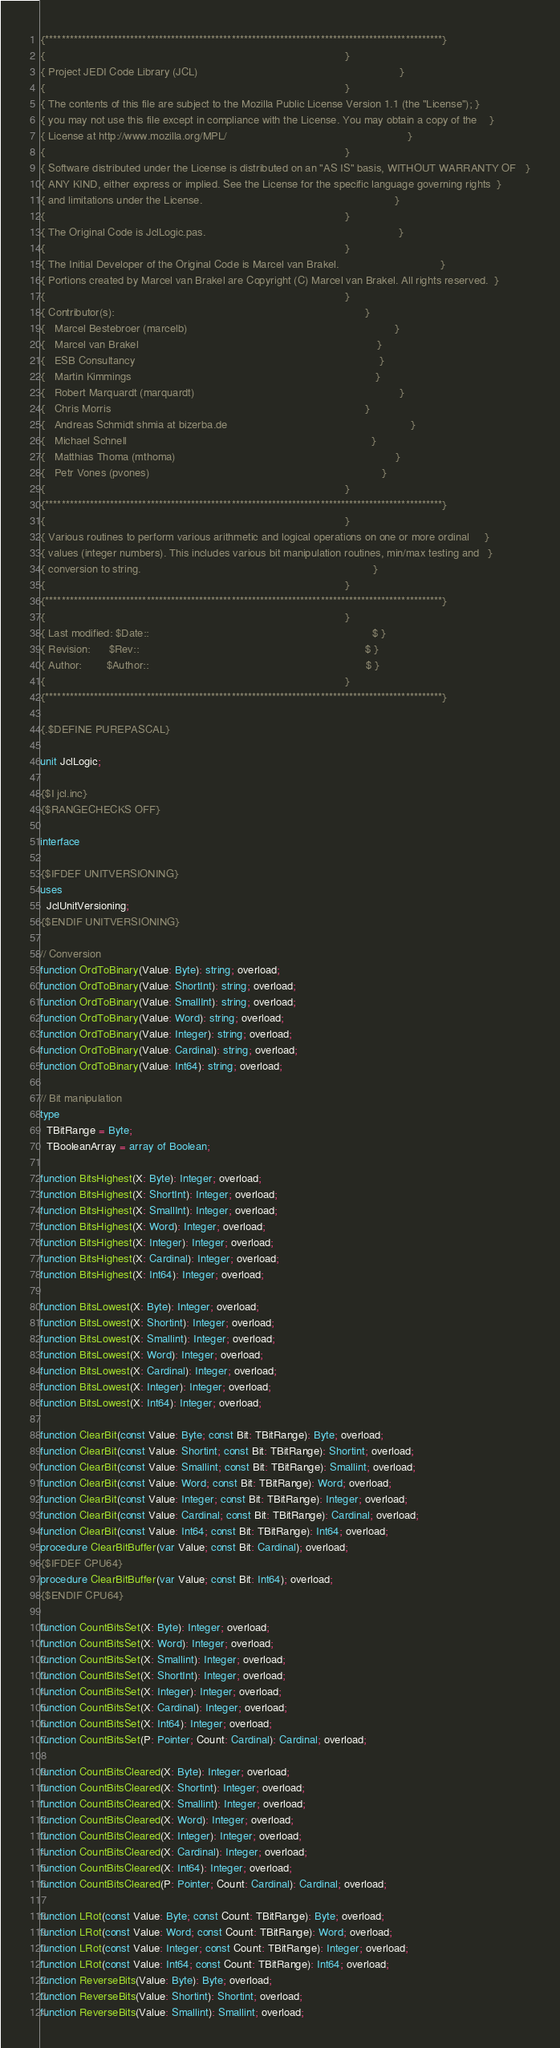<code> <loc_0><loc_0><loc_500><loc_500><_Pascal_>{**************************************************************************************************}
{                                                                                                  }
{ Project JEDI Code Library (JCL)                                                                  }
{                                                                                                  }
{ The contents of this file are subject to the Mozilla Public License Version 1.1 (the "License"); }
{ you may not use this file except in compliance with the License. You may obtain a copy of the    }
{ License at http://www.mozilla.org/MPL/                                                           }
{                                                                                                  }
{ Software distributed under the License is distributed on an "AS IS" basis, WITHOUT WARRANTY OF   }
{ ANY KIND, either express or implied. See the License for the specific language governing rights  }
{ and limitations under the License.                                                               }
{                                                                                                  }
{ The Original Code is JclLogic.pas.                                                               }
{                                                                                                  }
{ The Initial Developer of the Original Code is Marcel van Brakel.                                 }
{ Portions created by Marcel van Brakel are Copyright (C) Marcel van Brakel. All rights reserved.  }
{                                                                                                  }
{ Contributor(s):                                                                                  }
{   Marcel Bestebroer (marcelb)                                                                    }
{   Marcel van Brakel                                                                              }
{   ESB Consultancy                                                                                }
{   Martin Kimmings                                                                                }
{   Robert Marquardt (marquardt)                                                                   }
{   Chris Morris                                                                                   }
{   Andreas Schmidt shmia at bizerba.de                                                            }
{   Michael Schnell                                                                                }
{   Matthias Thoma (mthoma)                                                                        }
{   Petr Vones (pvones)                                                                            }
{                                                                                                  }
{**************************************************************************************************}
{                                                                                                  }
{ Various routines to perform various arithmetic and logical operations on one or more ordinal     }
{ values (integer numbers). This includes various bit manipulation routines, min/max testing and   }
{ conversion to string.                                                                            }
{                                                                                                  }
{**************************************************************************************************}
{                                                                                                  }
{ Last modified: $Date::                                                                         $ }
{ Revision:      $Rev::                                                                          $ }
{ Author:        $Author::                                                                       $ }
{                                                                                                  }
{**************************************************************************************************}

{.$DEFINE PUREPASCAL}

unit JclLogic;

{$I jcl.inc}
{$RANGECHECKS OFF}

interface

{$IFDEF UNITVERSIONING}
uses
  JclUnitVersioning;
{$ENDIF UNITVERSIONING}

// Conversion
function OrdToBinary(Value: Byte): string; overload;
function OrdToBinary(Value: ShortInt): string; overload;
function OrdToBinary(Value: SmallInt): string; overload;
function OrdToBinary(Value: Word): string; overload;
function OrdToBinary(Value: Integer): string; overload;
function OrdToBinary(Value: Cardinal): string; overload;
function OrdToBinary(Value: Int64): string; overload;

// Bit manipulation
type
  TBitRange = Byte;
  TBooleanArray = array of Boolean;

function BitsHighest(X: Byte): Integer; overload;
function BitsHighest(X: ShortInt): Integer; overload;
function BitsHighest(X: SmallInt): Integer; overload;
function BitsHighest(X: Word): Integer; overload;
function BitsHighest(X: Integer): Integer; overload;
function BitsHighest(X: Cardinal): Integer; overload;
function BitsHighest(X: Int64): Integer; overload;

function BitsLowest(X: Byte): Integer; overload;
function BitsLowest(X: Shortint): Integer; overload;
function BitsLowest(X: Smallint): Integer; overload;
function BitsLowest(X: Word): Integer; overload;
function BitsLowest(X: Cardinal): Integer; overload;
function BitsLowest(X: Integer): Integer; overload;
function BitsLowest(X: Int64): Integer; overload;

function ClearBit(const Value: Byte; const Bit: TBitRange): Byte; overload;
function ClearBit(const Value: Shortint; const Bit: TBitRange): Shortint; overload;
function ClearBit(const Value: Smallint; const Bit: TBitRange): Smallint; overload;
function ClearBit(const Value: Word; const Bit: TBitRange): Word; overload;
function ClearBit(const Value: Integer; const Bit: TBitRange): Integer; overload;
function ClearBit(const Value: Cardinal; const Bit: TBitRange): Cardinal; overload;
function ClearBit(const Value: Int64; const Bit: TBitRange): Int64; overload;
procedure ClearBitBuffer(var Value; const Bit: Cardinal); overload;
{$IFDEF CPU64}
procedure ClearBitBuffer(var Value; const Bit: Int64); overload;
{$ENDIF CPU64}

function CountBitsSet(X: Byte): Integer; overload;
function CountBitsSet(X: Word): Integer; overload;
function CountBitsSet(X: Smallint): Integer; overload;
function CountBitsSet(X: ShortInt): Integer; overload;
function CountBitsSet(X: Integer): Integer; overload;
function CountBitsSet(X: Cardinal): Integer; overload;
function CountBitsSet(X: Int64): Integer; overload;
function CountBitsSet(P: Pointer; Count: Cardinal): Cardinal; overload;

function CountBitsCleared(X: Byte): Integer; overload;
function CountBitsCleared(X: Shortint): Integer; overload;
function CountBitsCleared(X: Smallint): Integer; overload;
function CountBitsCleared(X: Word): Integer; overload;
function CountBitsCleared(X: Integer): Integer; overload;
function CountBitsCleared(X: Cardinal): Integer; overload;
function CountBitsCleared(X: Int64): Integer; overload;
function CountBitsCleared(P: Pointer; Count: Cardinal): Cardinal; overload;

function LRot(const Value: Byte; const Count: TBitRange): Byte; overload;
function LRot(const Value: Word; const Count: TBitRange): Word; overload;
function LRot(const Value: Integer; const Count: TBitRange): Integer; overload;
function LRot(const Value: Int64; const Count: TBitRange): Int64; overload;
function ReverseBits(Value: Byte): Byte; overload;
function ReverseBits(Value: Shortint): Shortint; overload;
function ReverseBits(Value: Smallint): Smallint; overload;</code> 